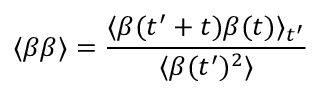Convert formula to latex. <formula><loc_0><loc_0><loc_500><loc_500>\langle \beta \beta \rangle = \frac { \langle \beta ( t ^ { \prime } + t ) \beta ( t ) \rangle _ { t ^ { \prime } } } { \langle \beta ( t ^ { \prime } ) ^ { 2 } \rangle }</formula> 